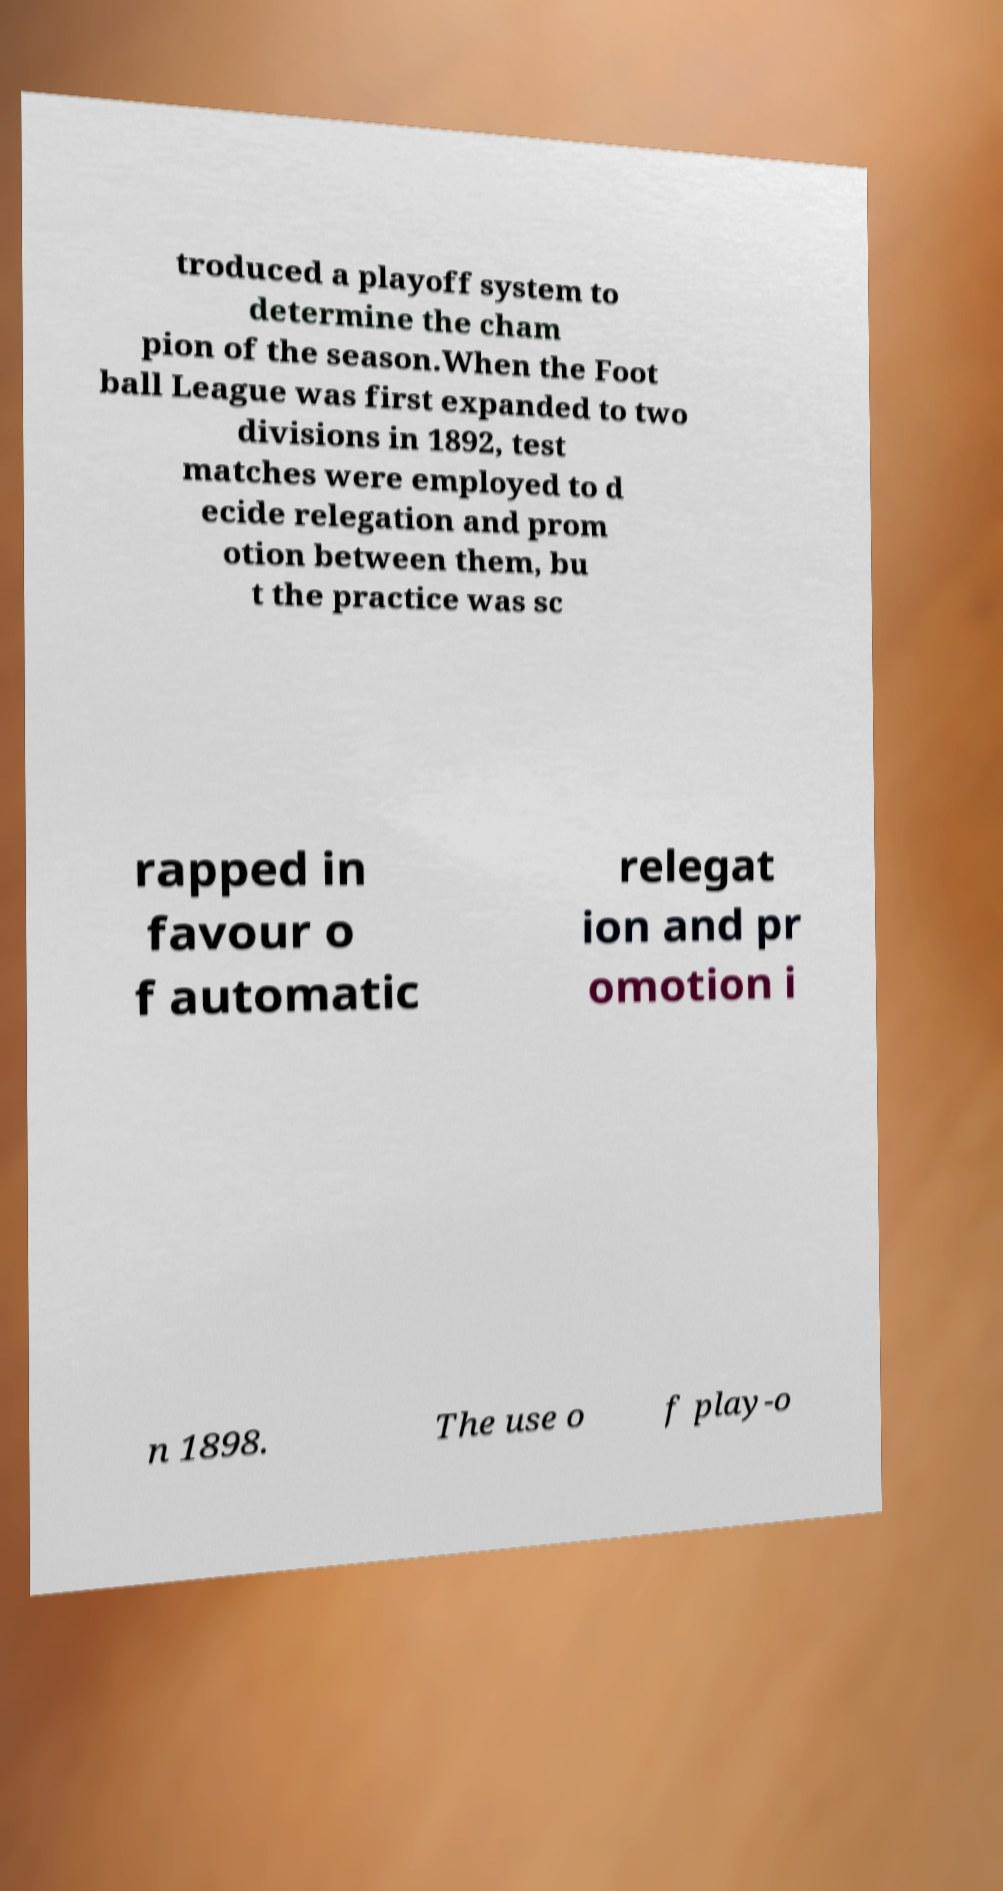There's text embedded in this image that I need extracted. Can you transcribe it verbatim? troduced a playoff system to determine the cham pion of the season.When the Foot ball League was first expanded to two divisions in 1892, test matches were employed to d ecide relegation and prom otion between them, bu t the practice was sc rapped in favour o f automatic relegat ion and pr omotion i n 1898. The use o f play-o 